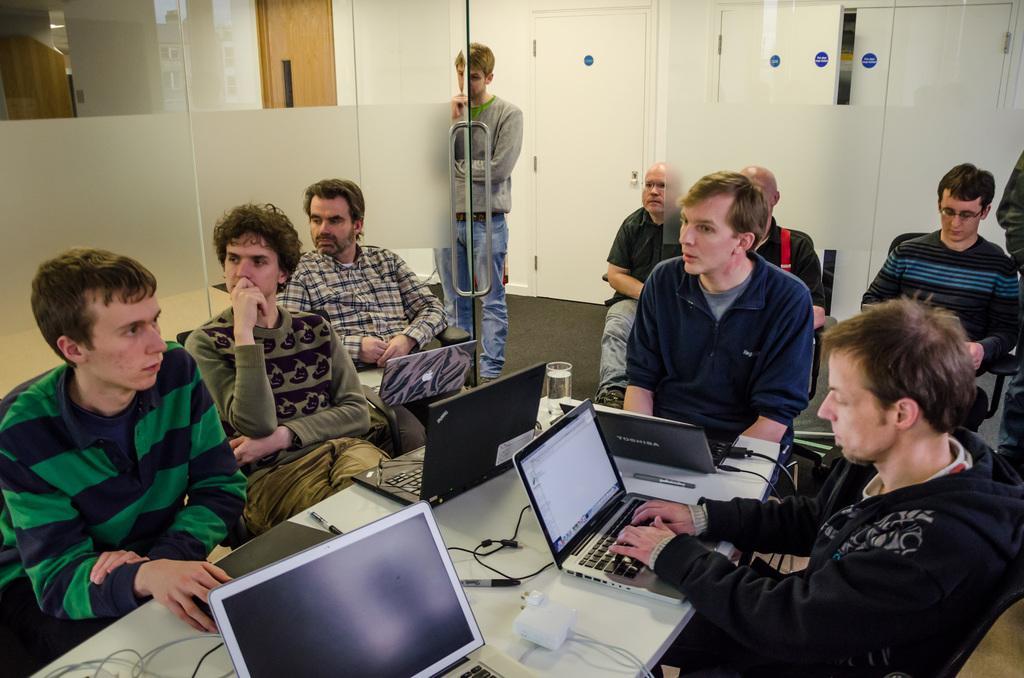How would you summarize this image in a sentence or two? Here we can see few people are sitting on the chairs and on the right a man is working on a laptop which is on a table and we can see laptops,adapter,cables,pens and a glass with water on the table. In the background we can see glass doors,doors and wall. 